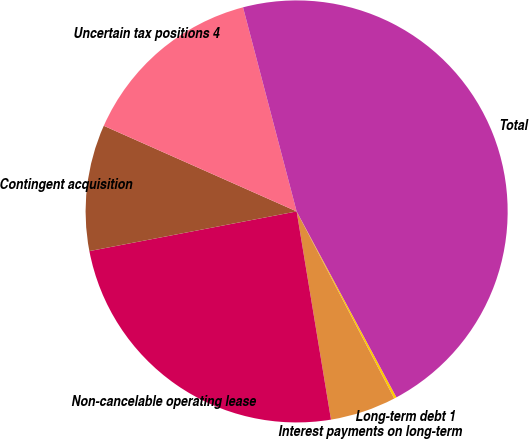<chart> <loc_0><loc_0><loc_500><loc_500><pie_chart><fcel>Long-term debt 1<fcel>Interest payments on long-term<fcel>Non-cancelable operating lease<fcel>Contingent acquisition<fcel>Uncertain tax positions 4<fcel>Total<nl><fcel>0.19%<fcel>5.05%<fcel>24.59%<fcel>9.66%<fcel>14.26%<fcel>46.24%<nl></chart> 